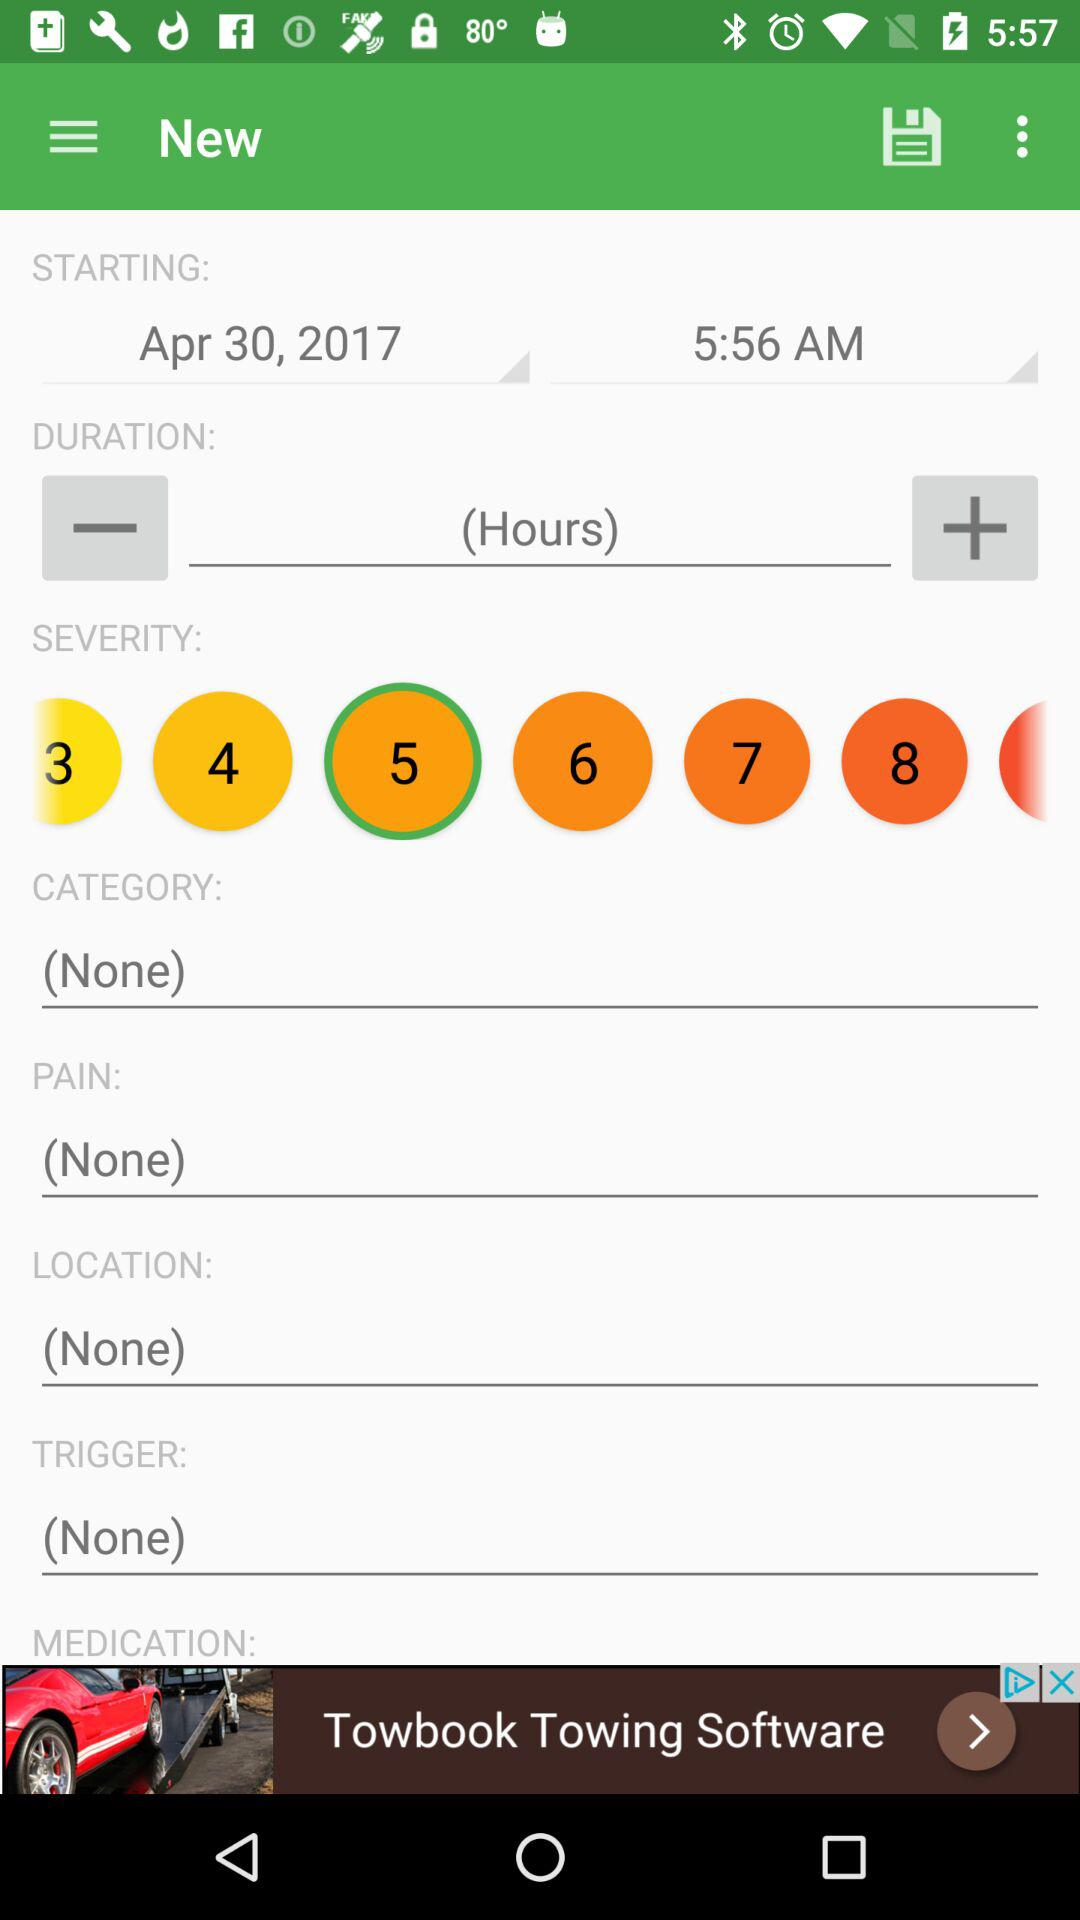What is the starting date? The starting date is April 30, 2017. 